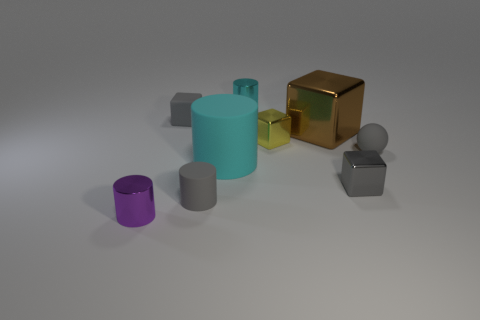How many other objects are there of the same color as the tiny rubber block?
Ensure brevity in your answer.  3. Is the color of the tiny matte cylinder the same as the small metallic cube to the right of the large cube?
Make the answer very short. Yes. How many blue things are tiny matte cubes or tiny matte things?
Give a very brief answer. 0. Are there the same number of gray matte cylinders behind the tiny yellow metal thing and tiny purple metallic cylinders?
Keep it short and to the point. No. Are there any other things that have the same size as the purple cylinder?
Your answer should be very brief. Yes. What is the color of the small rubber object that is the same shape as the small cyan shiny object?
Ensure brevity in your answer.  Gray. How many large things have the same shape as the small yellow metallic object?
Your response must be concise. 1. There is another tiny block that is the same color as the matte block; what is it made of?
Keep it short and to the point. Metal. How many gray blocks are there?
Keep it short and to the point. 2. Are there any tiny yellow cubes made of the same material as the small cyan cylinder?
Provide a succinct answer. Yes. 